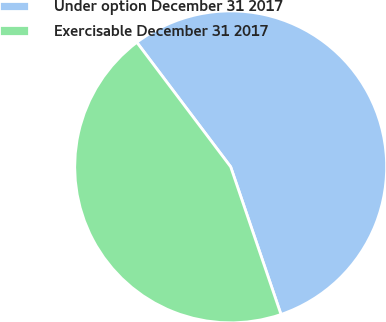Convert chart. <chart><loc_0><loc_0><loc_500><loc_500><pie_chart><fcel>Under option December 31 2017<fcel>Exercisable December 31 2017<nl><fcel>55.05%<fcel>44.95%<nl></chart> 